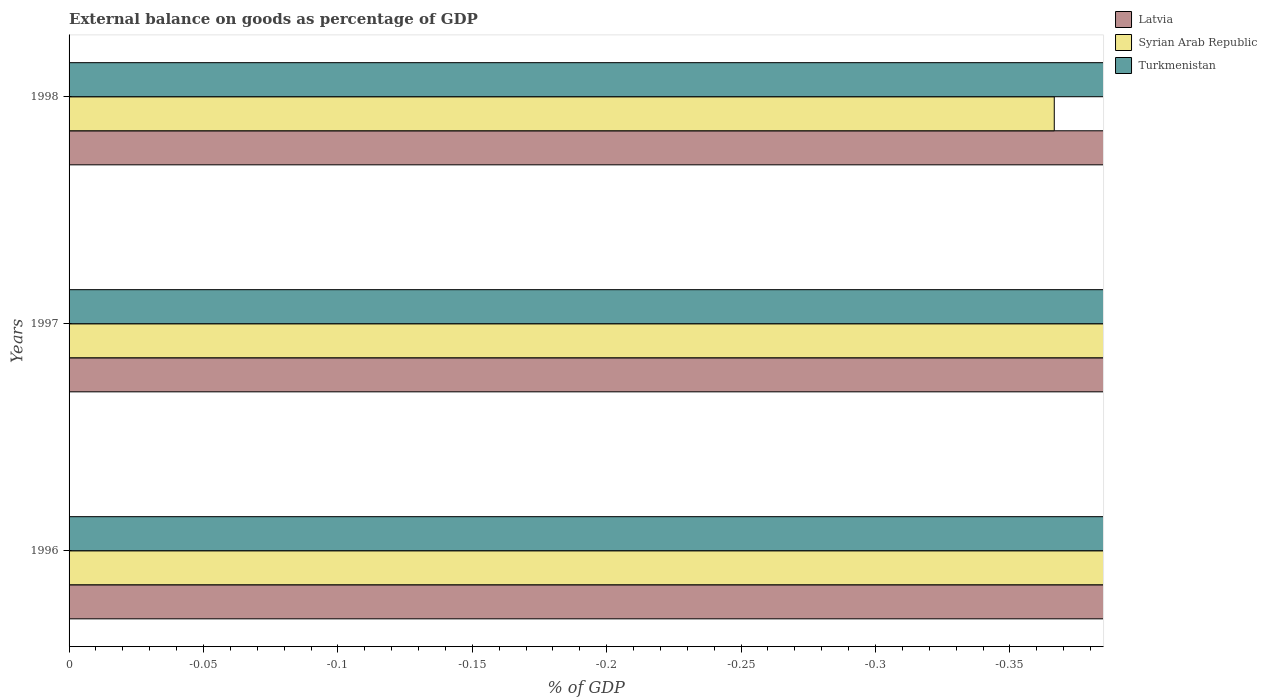Are the number of bars on each tick of the Y-axis equal?
Give a very brief answer. Yes. How many bars are there on the 1st tick from the top?
Your answer should be compact. 0. In how many cases, is the number of bars for a given year not equal to the number of legend labels?
Offer a terse response. 3. What is the external balance on goods as percentage of GDP in Turkmenistan in 1998?
Make the answer very short. 0. What is the total external balance on goods as percentage of GDP in Syrian Arab Republic in the graph?
Your response must be concise. 0. What is the difference between the external balance on goods as percentage of GDP in Latvia in 1998 and the external balance on goods as percentage of GDP in Syrian Arab Republic in 1997?
Your answer should be very brief. 0. How many bars are there?
Provide a short and direct response. 0. How many years are there in the graph?
Provide a short and direct response. 3. What is the difference between two consecutive major ticks on the X-axis?
Give a very brief answer. 0.05. Are the values on the major ticks of X-axis written in scientific E-notation?
Your answer should be compact. No. How are the legend labels stacked?
Give a very brief answer. Vertical. What is the title of the graph?
Your answer should be very brief. External balance on goods as percentage of GDP. What is the label or title of the X-axis?
Provide a short and direct response. % of GDP. What is the label or title of the Y-axis?
Make the answer very short. Years. What is the % of GDP of Turkmenistan in 1996?
Ensure brevity in your answer.  0. What is the % of GDP in Syrian Arab Republic in 1997?
Ensure brevity in your answer.  0. What is the % of GDP of Latvia in 1998?
Make the answer very short. 0. What is the % of GDP in Turkmenistan in 1998?
Your response must be concise. 0. What is the total % of GDP of Latvia in the graph?
Give a very brief answer. 0. 